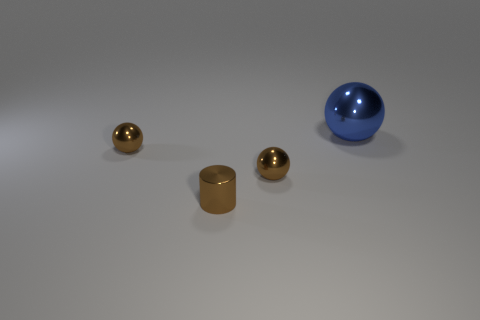Subtract all red spheres. Subtract all blue blocks. How many spheres are left? 3 Add 2 cylinders. How many objects exist? 6 Subtract all balls. How many objects are left? 1 Subtract all tiny brown metallic cylinders. Subtract all large metal objects. How many objects are left? 2 Add 1 blue spheres. How many blue spheres are left? 2 Add 4 small cylinders. How many small cylinders exist? 5 Subtract 0 cyan cylinders. How many objects are left? 4 